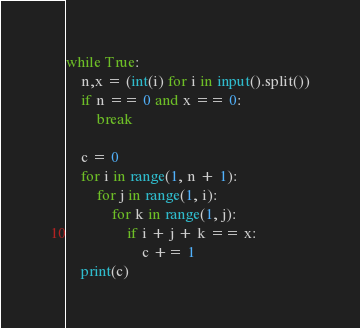<code> <loc_0><loc_0><loc_500><loc_500><_Python_>while True:
    n,x = (int(i) for i in input().split())
    if n == 0 and x == 0:
        break

    c = 0
    for i in range(1, n + 1):
        for j in range(1, i):
            for k in range(1, j):
                if i + j + k == x:
                    c += 1
    print(c)
</code> 